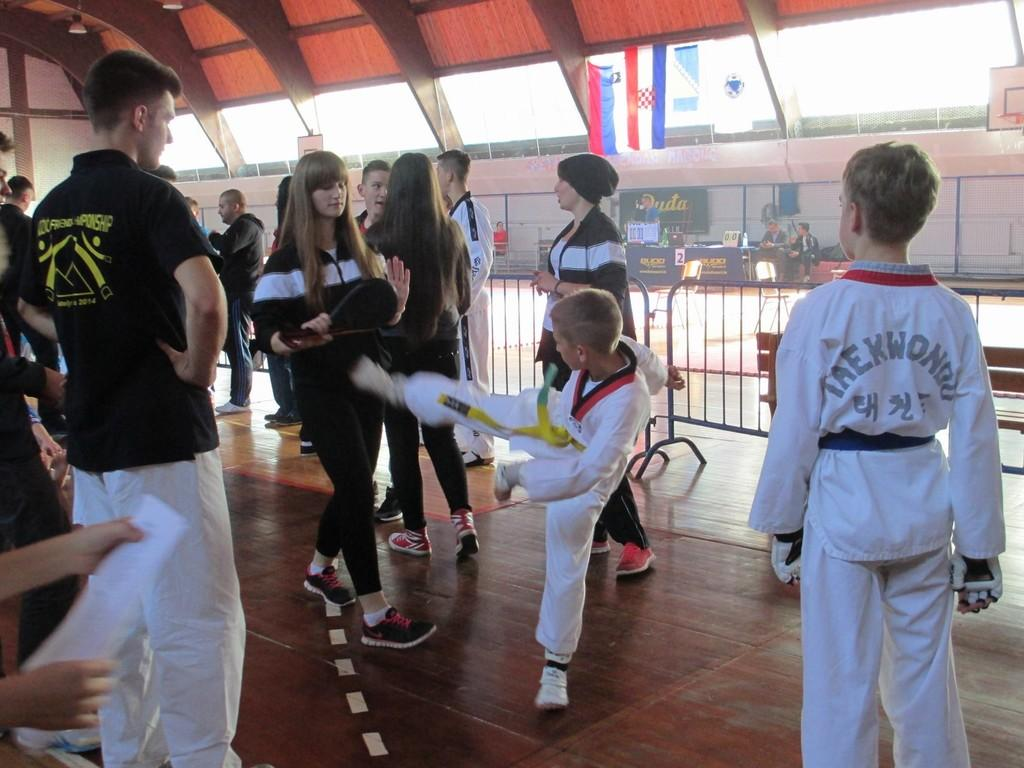<image>
Create a compact narrative representing the image presented. A group of people wearing track suits and white uniforms take part in a Taekwondo session. 